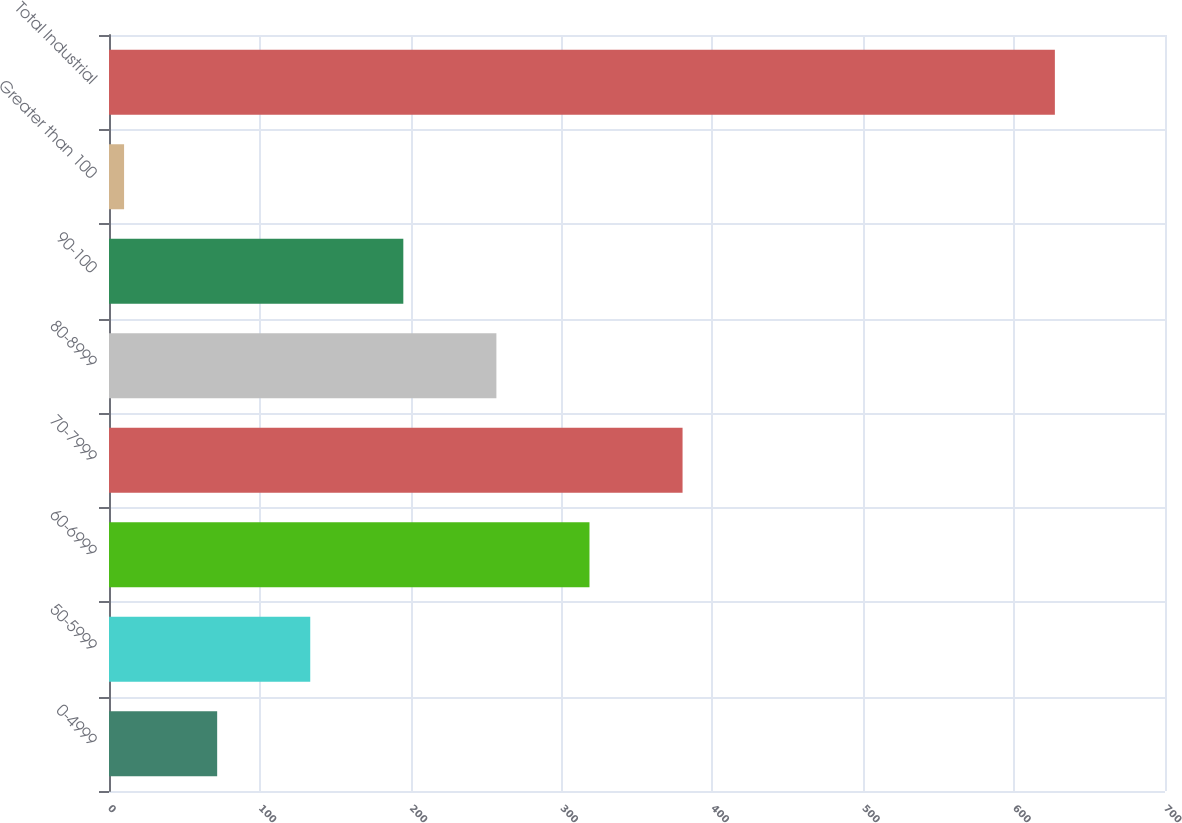Convert chart. <chart><loc_0><loc_0><loc_500><loc_500><bar_chart><fcel>0-4999<fcel>50-5999<fcel>60-6999<fcel>70-7999<fcel>80-8999<fcel>90-100<fcel>Greater than 100<fcel>Total Industrial<nl><fcel>71.7<fcel>133.4<fcel>318.5<fcel>380.2<fcel>256.8<fcel>195.1<fcel>10<fcel>627<nl></chart> 